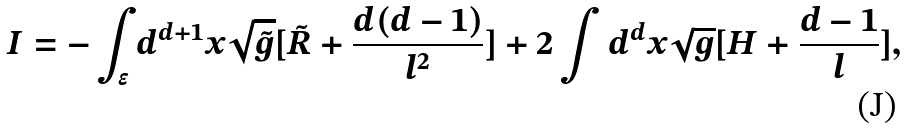Convert formula to latex. <formula><loc_0><loc_0><loc_500><loc_500>I = - \int _ { \epsilon } d ^ { d + 1 } x \sqrt { \tilde { g } } [ \tilde { R } + \frac { d ( d - 1 ) } { l ^ { 2 } } ] + 2 \int d ^ { d } x \sqrt { g } [ H + \frac { d - 1 } l ] ,</formula> 